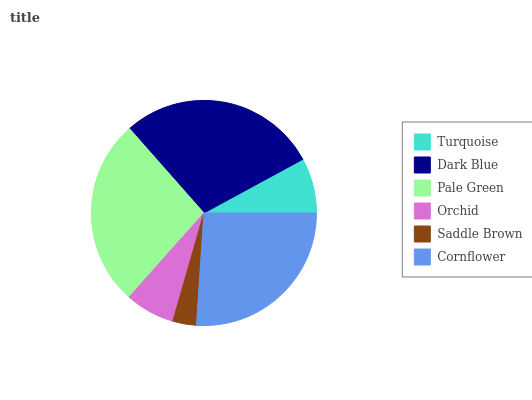Is Saddle Brown the minimum?
Answer yes or no. Yes. Is Dark Blue the maximum?
Answer yes or no. Yes. Is Pale Green the minimum?
Answer yes or no. No. Is Pale Green the maximum?
Answer yes or no. No. Is Dark Blue greater than Pale Green?
Answer yes or no. Yes. Is Pale Green less than Dark Blue?
Answer yes or no. Yes. Is Pale Green greater than Dark Blue?
Answer yes or no. No. Is Dark Blue less than Pale Green?
Answer yes or no. No. Is Cornflower the high median?
Answer yes or no. Yes. Is Turquoise the low median?
Answer yes or no. Yes. Is Turquoise the high median?
Answer yes or no. No. Is Cornflower the low median?
Answer yes or no. No. 